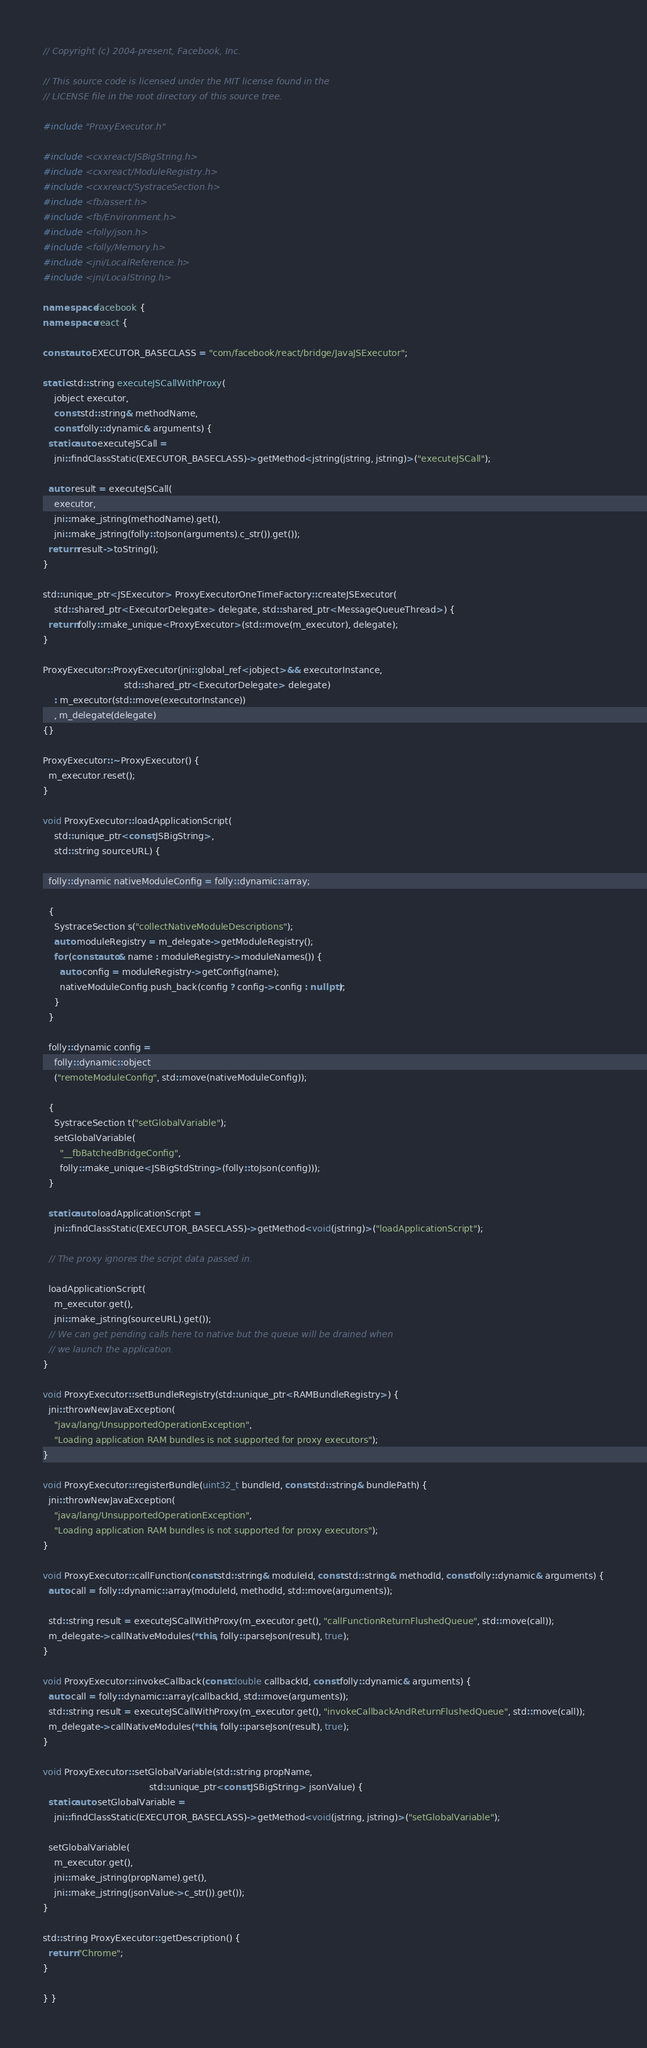Convert code to text. <code><loc_0><loc_0><loc_500><loc_500><_C++_>// Copyright (c) 2004-present, Facebook, Inc.

// This source code is licensed under the MIT license found in the
// LICENSE file in the root directory of this source tree.

#include "ProxyExecutor.h"

#include <cxxreact/JSBigString.h>
#include <cxxreact/ModuleRegistry.h>
#include <cxxreact/SystraceSection.h>
#include <fb/assert.h>
#include <fb/Environment.h>
#include <folly/json.h>
#include <folly/Memory.h>
#include <jni/LocalReference.h>
#include <jni/LocalString.h>

namespace facebook {
namespace react {

const auto EXECUTOR_BASECLASS = "com/facebook/react/bridge/JavaJSExecutor";

static std::string executeJSCallWithProxy(
    jobject executor,
    const std::string& methodName,
    const folly::dynamic& arguments) {
  static auto executeJSCall =
    jni::findClassStatic(EXECUTOR_BASECLASS)->getMethod<jstring(jstring, jstring)>("executeJSCall");

  auto result = executeJSCall(
    executor,
    jni::make_jstring(methodName).get(),
    jni::make_jstring(folly::toJson(arguments).c_str()).get());
  return result->toString();
}

std::unique_ptr<JSExecutor> ProxyExecutorOneTimeFactory::createJSExecutor(
    std::shared_ptr<ExecutorDelegate> delegate, std::shared_ptr<MessageQueueThread>) {
  return folly::make_unique<ProxyExecutor>(std::move(m_executor), delegate);
}

ProxyExecutor::ProxyExecutor(jni::global_ref<jobject>&& executorInstance,
                             std::shared_ptr<ExecutorDelegate> delegate)
    : m_executor(std::move(executorInstance))
    , m_delegate(delegate)
{}

ProxyExecutor::~ProxyExecutor() {
  m_executor.reset();
}

void ProxyExecutor::loadApplicationScript(
    std::unique_ptr<const JSBigString>,
    std::string sourceURL) {

  folly::dynamic nativeModuleConfig = folly::dynamic::array;

  {
    SystraceSection s("collectNativeModuleDescriptions");
    auto moduleRegistry = m_delegate->getModuleRegistry();
    for (const auto& name : moduleRegistry->moduleNames()) {
      auto config = moduleRegistry->getConfig(name);
      nativeModuleConfig.push_back(config ? config->config : nullptr);
    }
  }

  folly::dynamic config =
    folly::dynamic::object
    ("remoteModuleConfig", std::move(nativeModuleConfig));

  {
    SystraceSection t("setGlobalVariable");
    setGlobalVariable(
      "__fbBatchedBridgeConfig",
      folly::make_unique<JSBigStdString>(folly::toJson(config)));
  }

  static auto loadApplicationScript =
    jni::findClassStatic(EXECUTOR_BASECLASS)->getMethod<void(jstring)>("loadApplicationScript");

  // The proxy ignores the script data passed in.

  loadApplicationScript(
    m_executor.get(),
    jni::make_jstring(sourceURL).get());
  // We can get pending calls here to native but the queue will be drained when
  // we launch the application.
}

void ProxyExecutor::setBundleRegistry(std::unique_ptr<RAMBundleRegistry>) {
  jni::throwNewJavaException(
    "java/lang/UnsupportedOperationException",
    "Loading application RAM bundles is not supported for proxy executors");
}

void ProxyExecutor::registerBundle(uint32_t bundleId, const std::string& bundlePath) {
  jni::throwNewJavaException(
    "java/lang/UnsupportedOperationException",
    "Loading application RAM bundles is not supported for proxy executors");
}

void ProxyExecutor::callFunction(const std::string& moduleId, const std::string& methodId, const folly::dynamic& arguments) {
  auto call = folly::dynamic::array(moduleId, methodId, std::move(arguments));

  std::string result = executeJSCallWithProxy(m_executor.get(), "callFunctionReturnFlushedQueue", std::move(call));
  m_delegate->callNativeModules(*this, folly::parseJson(result), true);
}

void ProxyExecutor::invokeCallback(const double callbackId, const folly::dynamic& arguments) {
  auto call = folly::dynamic::array(callbackId, std::move(arguments));
  std::string result = executeJSCallWithProxy(m_executor.get(), "invokeCallbackAndReturnFlushedQueue", std::move(call));
  m_delegate->callNativeModules(*this, folly::parseJson(result), true);
}

void ProxyExecutor::setGlobalVariable(std::string propName,
                                      std::unique_ptr<const JSBigString> jsonValue) {
  static auto setGlobalVariable =
    jni::findClassStatic(EXECUTOR_BASECLASS)->getMethod<void(jstring, jstring)>("setGlobalVariable");

  setGlobalVariable(
    m_executor.get(),
    jni::make_jstring(propName).get(),
    jni::make_jstring(jsonValue->c_str()).get());
}

std::string ProxyExecutor::getDescription() {
  return "Chrome";
}

} }
</code> 